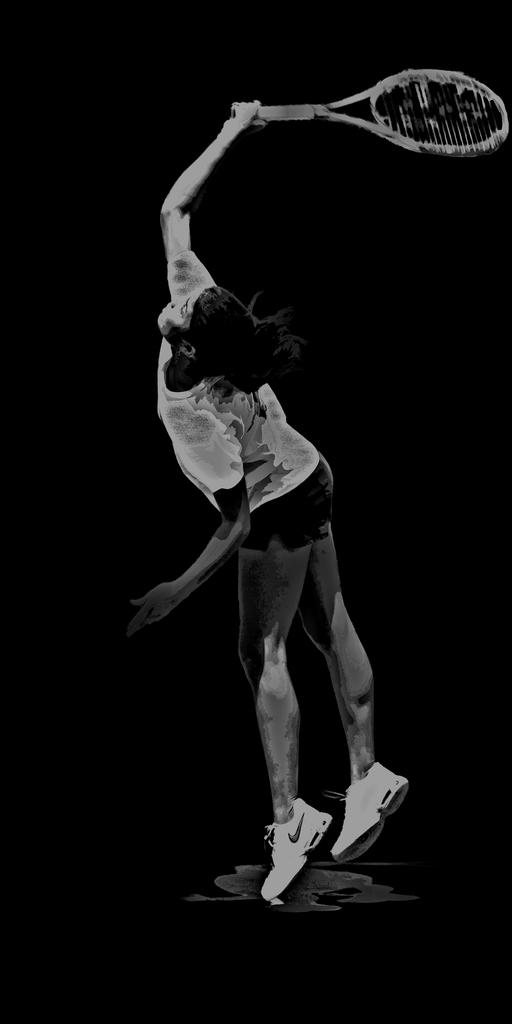Who is present in the image? There is: There is a woman in the image. What is the woman holding in the image? The woman is holding a bat. What can be observed about the background of the image? The background of the image is dark. How many babies are visible in the image? There are no babies present in the image; it features a woman holding a bat. What type of glove is the woman wearing in the image? The woman is not wearing a glove in the image; she is holding a bat. 